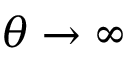<formula> <loc_0><loc_0><loc_500><loc_500>\theta \rightarrow \infty</formula> 